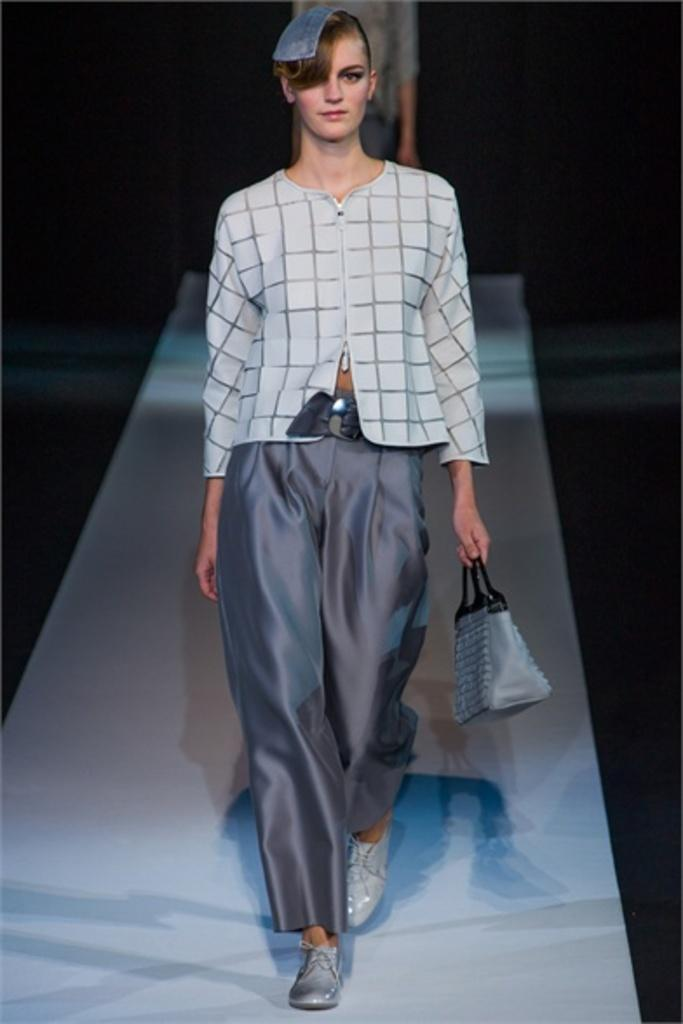Who is the main subject in the image? There is a woman in the image. What is the woman doing in the image? The woman is walking. What object is the woman holding in the image? The woman is holding a handbag. What type of meat is the woman thinking about in the image? There is no indication in the image that the woman is thinking about meat or any other food item. 